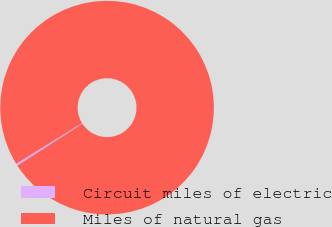Convert chart to OTSL. <chart><loc_0><loc_0><loc_500><loc_500><pie_chart><fcel>Circuit miles of electric<fcel>Miles of natural gas<nl><fcel>0.33%<fcel>99.67%<nl></chart> 